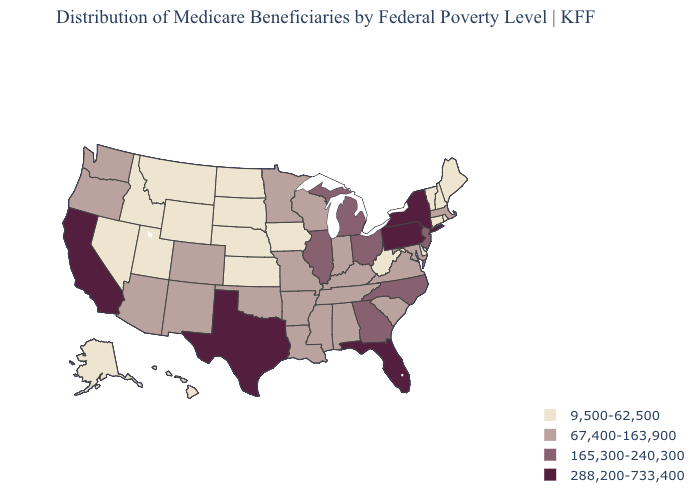What is the value of Alabama?
Be succinct. 67,400-163,900. Name the states that have a value in the range 288,200-733,400?
Write a very short answer. California, Florida, New York, Pennsylvania, Texas. Does Mississippi have a higher value than Montana?
Write a very short answer. Yes. Among the states that border Vermont , which have the lowest value?
Short answer required. New Hampshire. Name the states that have a value in the range 165,300-240,300?
Be succinct. Georgia, Illinois, Michigan, New Jersey, North Carolina, Ohio. What is the value of Massachusetts?
Quick response, please. 67,400-163,900. How many symbols are there in the legend?
Concise answer only. 4. Name the states that have a value in the range 9,500-62,500?
Be succinct. Alaska, Connecticut, Delaware, Hawaii, Idaho, Iowa, Kansas, Maine, Montana, Nebraska, Nevada, New Hampshire, North Dakota, Rhode Island, South Dakota, Utah, Vermont, West Virginia, Wyoming. Name the states that have a value in the range 288,200-733,400?
Answer briefly. California, Florida, New York, Pennsylvania, Texas. What is the value of Kentucky?
Short answer required. 67,400-163,900. Name the states that have a value in the range 165,300-240,300?
Concise answer only. Georgia, Illinois, Michigan, New Jersey, North Carolina, Ohio. Among the states that border Washington , does Oregon have the highest value?
Keep it brief. Yes. Name the states that have a value in the range 288,200-733,400?
Give a very brief answer. California, Florida, New York, Pennsylvania, Texas. Does the map have missing data?
Be succinct. No. Name the states that have a value in the range 165,300-240,300?
Quick response, please. Georgia, Illinois, Michigan, New Jersey, North Carolina, Ohio. 